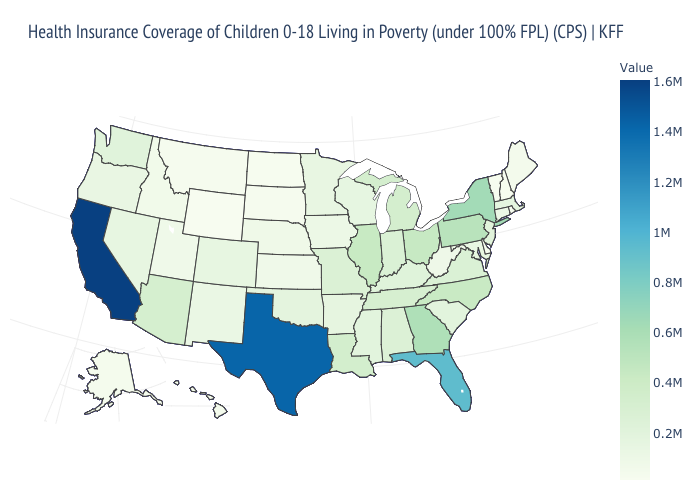Among the states that border Pennsylvania , which have the highest value?
Answer briefly. New York. 